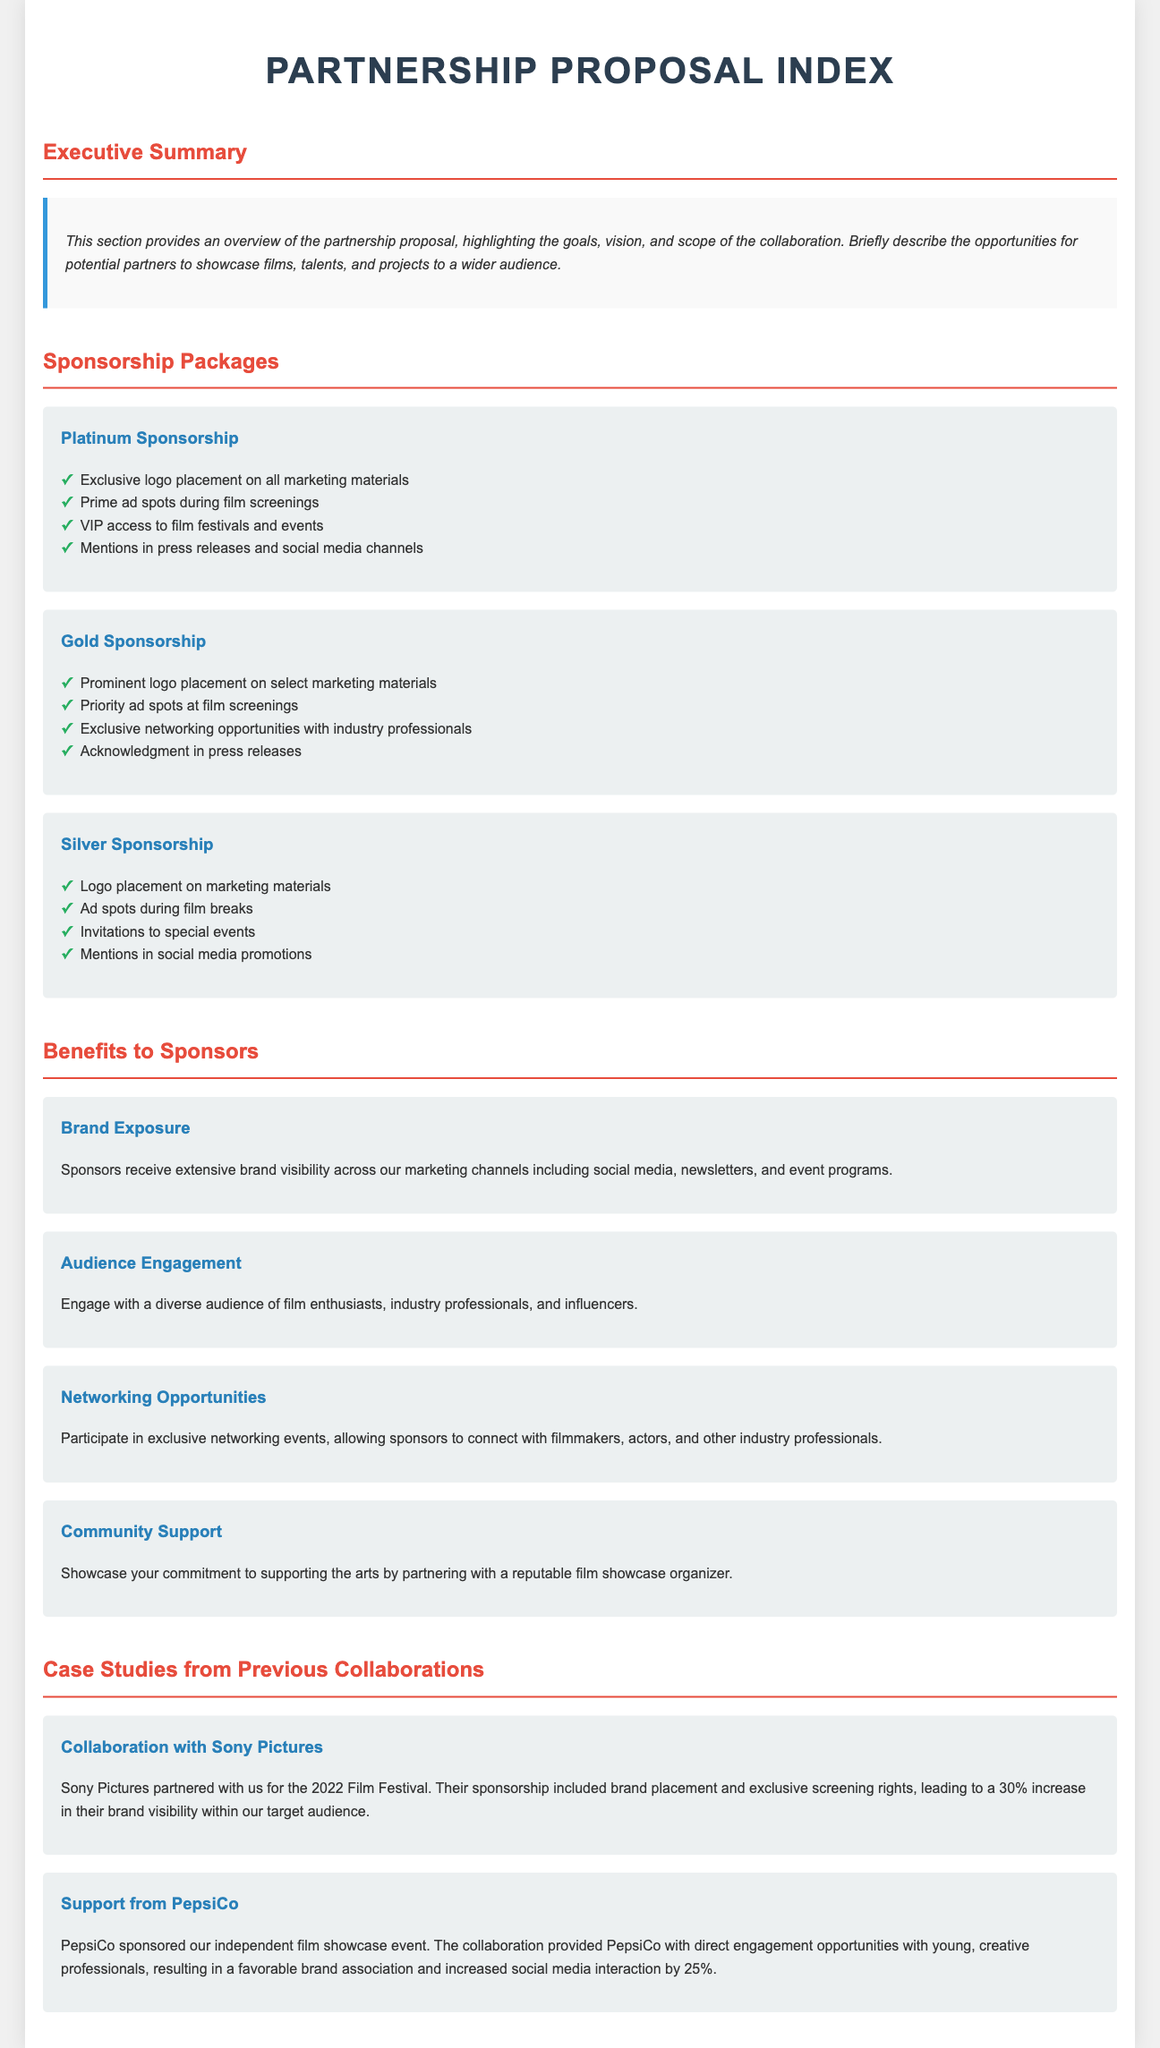what is the title of the document? The title of the document is found at the top of the rendered document, which shows the main subject of the content.
Answer: Partnership Proposal Index how many sponsorship packages are offered? The count of sponsorship packages can be found listed in the section titled "Sponsorship Packages."
Answer: 3 what is one benefit of sponsorship mentioned? The benefits section lists several advantages that sponsors receive, any one of those can be used as an answer.
Answer: Brand Exposure which company partnered for the 2022 Film Festival? A specific case study mentions a collaboration with a well-known film company, indicating their participation in an event.
Answer: Sony Pictures what is the color of the headings in the document? The document specifies a specific color aesthetic for headings that contributes to its visual design.
Answer: #e74c3c what is the key opportunity provided to sponsors? The document details the incentives to sponsors, summarizing what they gain from the partnership based on various sections.
Answer: Networking Opportunities how much did PepsiCo's social media interaction increase by? The case study describes the impact of PepsiCo's event sponsorship on its brand engagement, providing a specific numerical increase.
Answer: 25% what is the primary target audience for the sponsors? The audience type can be inferred from the document contents, particularly in sections that speak about engagement and exposure.
Answer: Young, creative professionals where can sponsors place their logos in the Platinum Sponsorship? The specific marketing materials mentioned in the sponsorship packages provide a clear answer for location specifics.
Answer: All marketing materials 